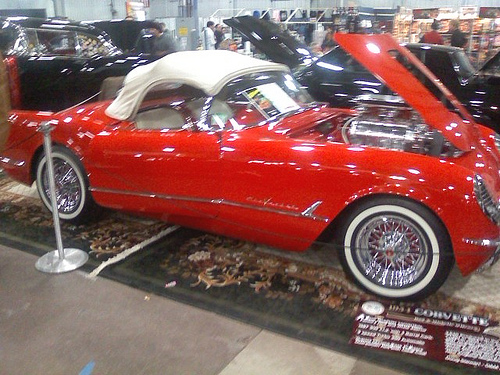<image>
Is there a car on the carpet? Yes. Looking at the image, I can see the car is positioned on top of the carpet, with the carpet providing support. Is there a rug in front of the car? No. The rug is not in front of the car. The spatial positioning shows a different relationship between these objects. 